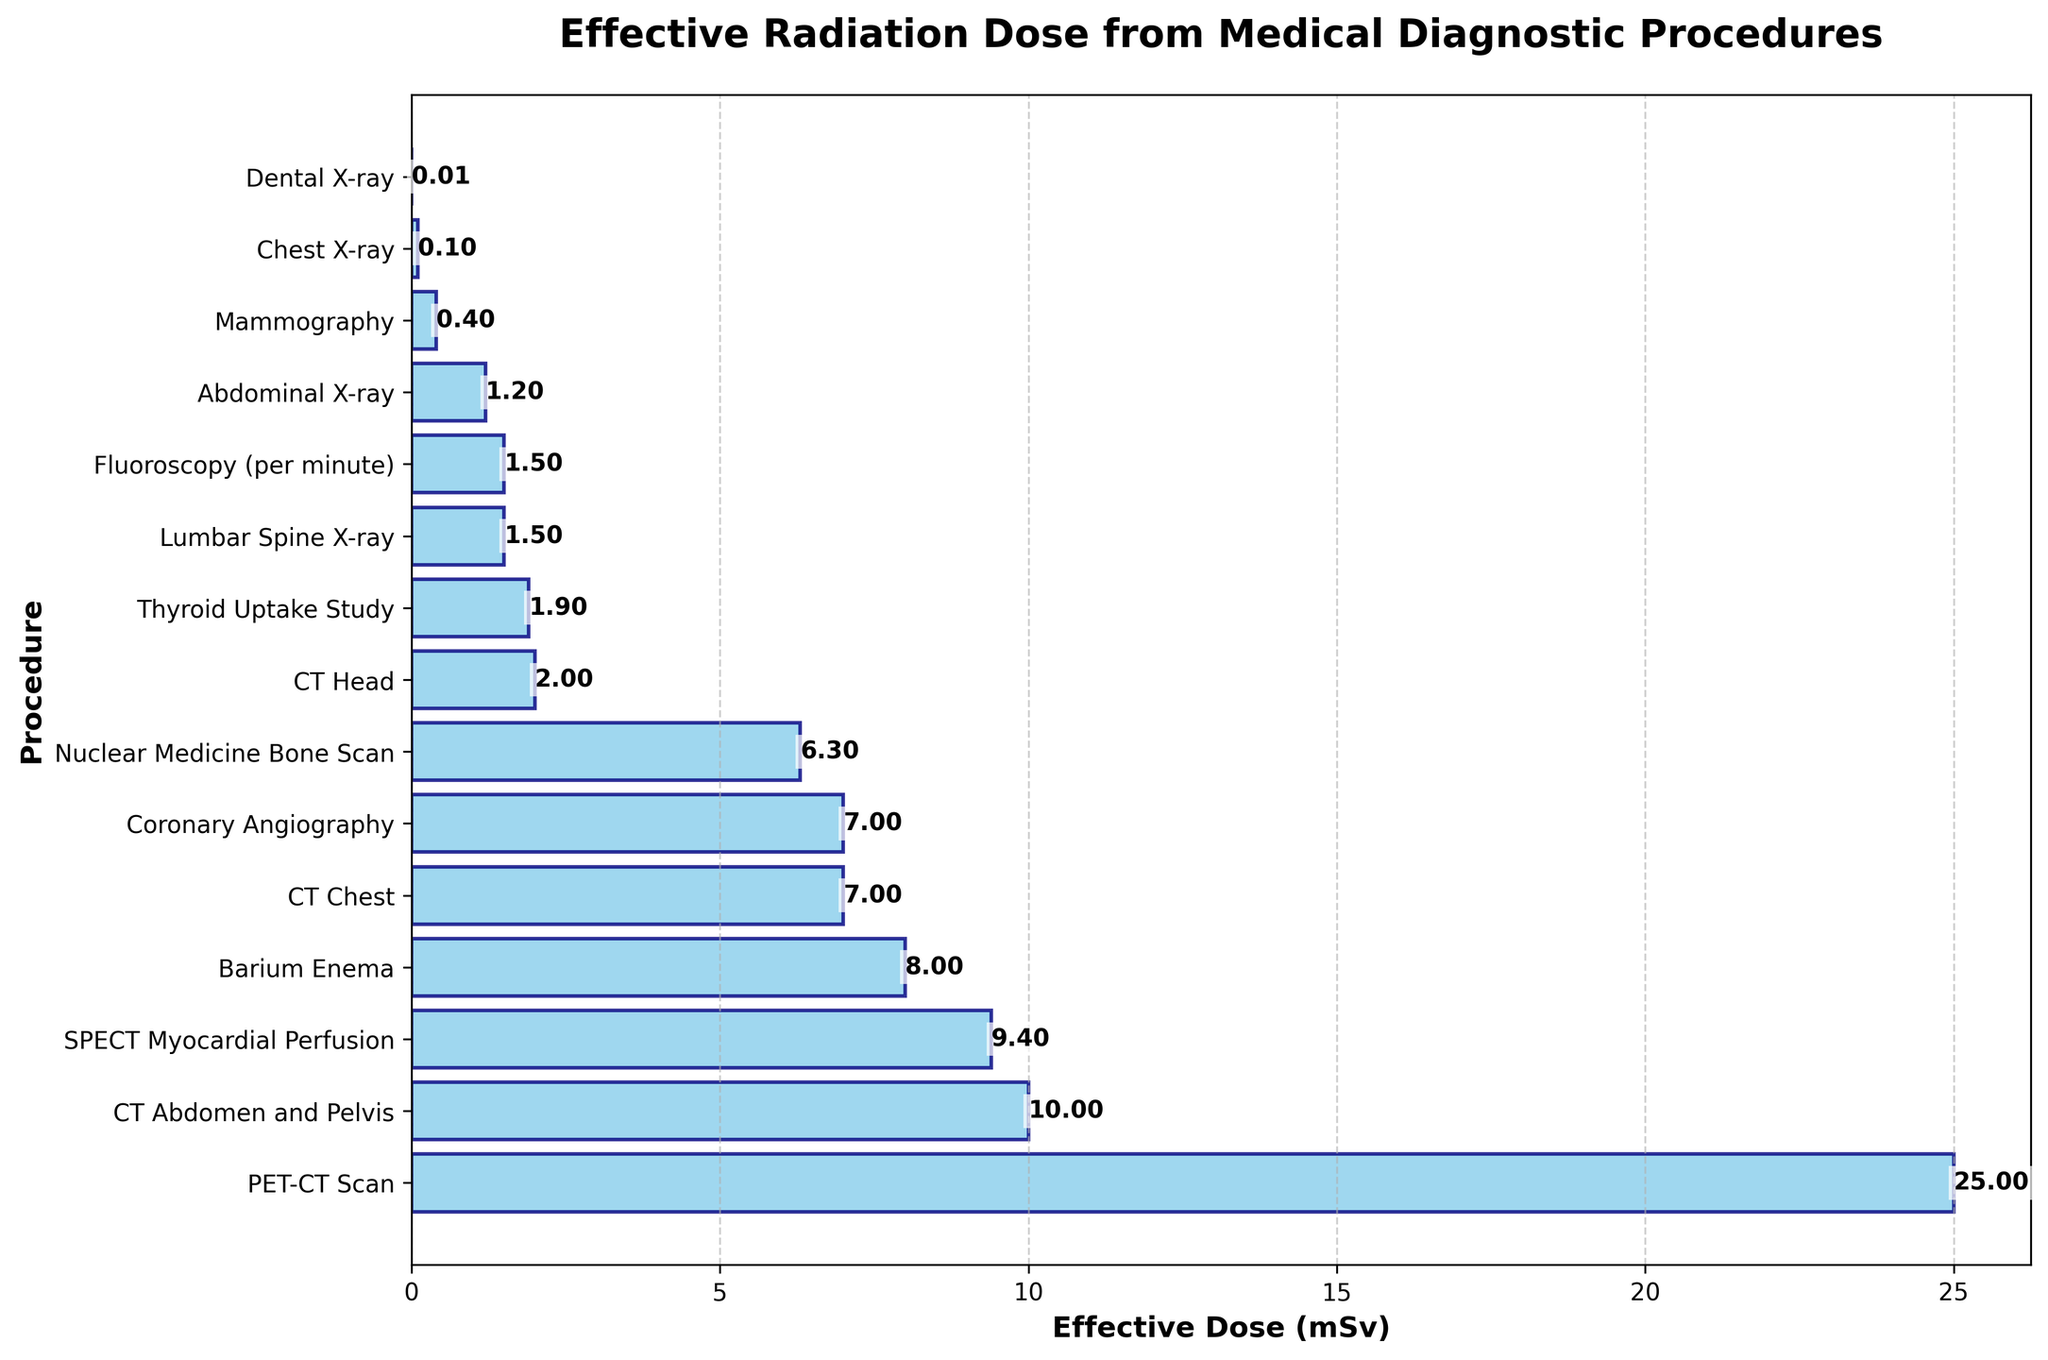What's the procedure with the highest radiation dose? The figure shows a horizontal bar chart with the procedures and their respective radiation doses. The longest bar corresponds to the highest value. The longest bar is next to "PET-CT Scan", indicating it has the highest dose.
Answer: PET-CT Scan What's the total radiation dose of a CT Chest and a CT Abdomen and Pelvis? We need to locate the bars for "CT Chest" and "CT Abdomen and Pelvis" and sum their doses. "CT Chest" has a dose of 7.0 mSv, and "CT Abdomen and Pelvis" has a dose of 10.0 mSv. Summing them gives 7.0 + 10.0 = 17.0 mSv.
Answer: 17.0 mSv How does the radiation dose of a Dental X-ray compare to that of a Chest X-ray? Find the doses of both procedures in the chart. A Dental X-ray is 0.005 mSv, and a Chest X-ray is 0.1 mSv. By comparing, the Chest X-ray's dose is larger.
Answer: Chest X-ray's dose is larger What is the average dose of a Barium Enema and a Mammography? Locate the doses for "Barium Enema" and "Mammography". They are 8.0 mSv and 0.4 mSv, respectively. The average is calculated as (8.0 + 0.4) / 2 = 4.2 mSv.
Answer: 4.2 mSv Which procedure has a lower dose: Nuclear Medicine Bone Scan or CT Head? Check the bars for both "Nuclear Medicine Bone Scan" and "CT Head". "Nuclear Medicine Bone Scan" shows 6.3 mSv, while "CT Head" shows 2.0 mSv. The procedure with a lower dose is CT Head.
Answer: CT Head Is the radiation dose of SPECT Myocardial Perfusion greater than the average dose of a Fluoroscopy (per minute) and a Thyroid Uptake Study? Calculate the average dose of Fluoroscopy (1.5 mSv) and Thyroid Uptake Study (1.9 mSv) first: (1.5 + 1.9) / 2 = 1.7 mSv. Compare this average to SPECT Myocardial Perfusion's dose (9.4 mSv), which is greater.
Answer: Yes What is the difference in radiation dose between the highest and lowest dose procedures? Identify the highest dose (PET-CT Scan at 25 mSv) and the lowest dose (Dental X-ray at 0.005 mSv). The difference is calculated as 25 - 0.005 = 24.995 mSv.
Answer: 24.995 mSv Which two procedures have exactly the same radiation dose? Examine the bars to identify any pairs with the same length. "Fluoroscopy (per minute)" and "Lumbar Spine X-ray" both have doses of 1.5 mSv, making them equal.
Answer: Fluoroscopy (per minute), Lumbar Spine X-ray What's the median radiation dose of the plotted procedures? Arrange all doses in ascending order and find the middle value(s). The doses are: 0.005, 0.1, 0.4, 1.2, 1.5, 1.5, 1.9, 2.0, 6.3, 7.0, 7.0, 8.0, 9.4, 10.0, 25. The median values are the 7th and 8th: (1.9 + 2.0) / 2 = 1.95 mSv.
Answer: 1.95 mSv 